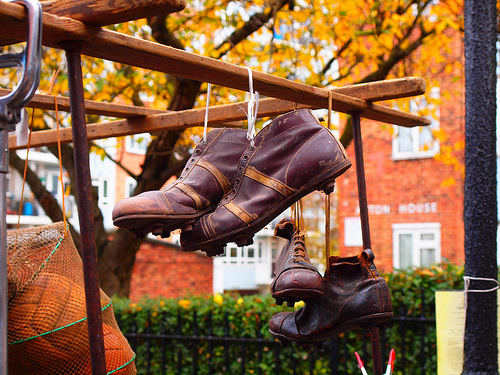<image>
Is there a shoe to the right of the shoe? No. The shoe is not to the right of the shoe. The horizontal positioning shows a different relationship. 